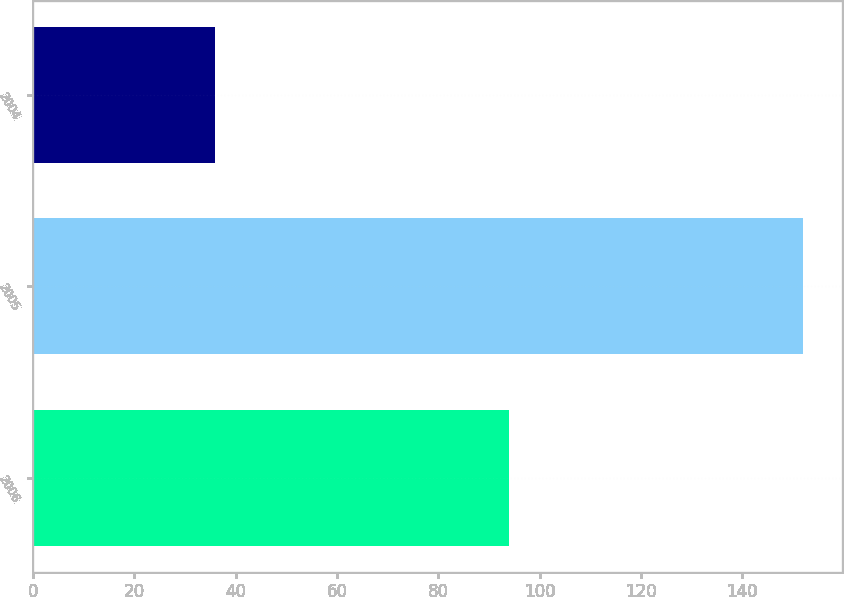Convert chart to OTSL. <chart><loc_0><loc_0><loc_500><loc_500><bar_chart><fcel>2006<fcel>2005<fcel>2004<nl><fcel>94<fcel>152<fcel>36<nl></chart> 